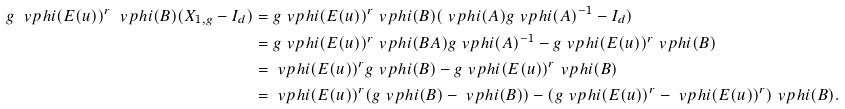<formula> <loc_0><loc_0><loc_500><loc_500>g \ v p h i ( E ( u ) ) ^ { r } \ v p h i ( B ) ( X _ { 1 , g } - I _ { d } ) & = g \ v p h i ( E ( u ) ) ^ { r } \ v p h i ( B ) ( \ v p h i ( A ) g \ v p h i ( A ) ^ { - 1 } - I _ { d } ) \\ & = g \ v p h i ( E ( u ) ) ^ { r } \ v p h i ( B A ) g \ v p h i ( A ) ^ { - 1 } - g \ v p h i ( E ( u ) ) ^ { r } \ v p h i ( B ) \\ & = \ v p h i ( E ( u ) ) ^ { r } g \ v p h i ( B ) - g \ v p h i ( E ( u ) ) ^ { r } \ v p h i ( B ) \\ & = \ v p h i ( E ( u ) ) ^ { r } ( g \ v p h i ( B ) - \ v p h i ( B ) ) - ( g \ v p h i ( E ( u ) ) ^ { r } - \ v p h i ( E ( u ) ) ^ { r } ) \ v p h i ( B ) .</formula> 